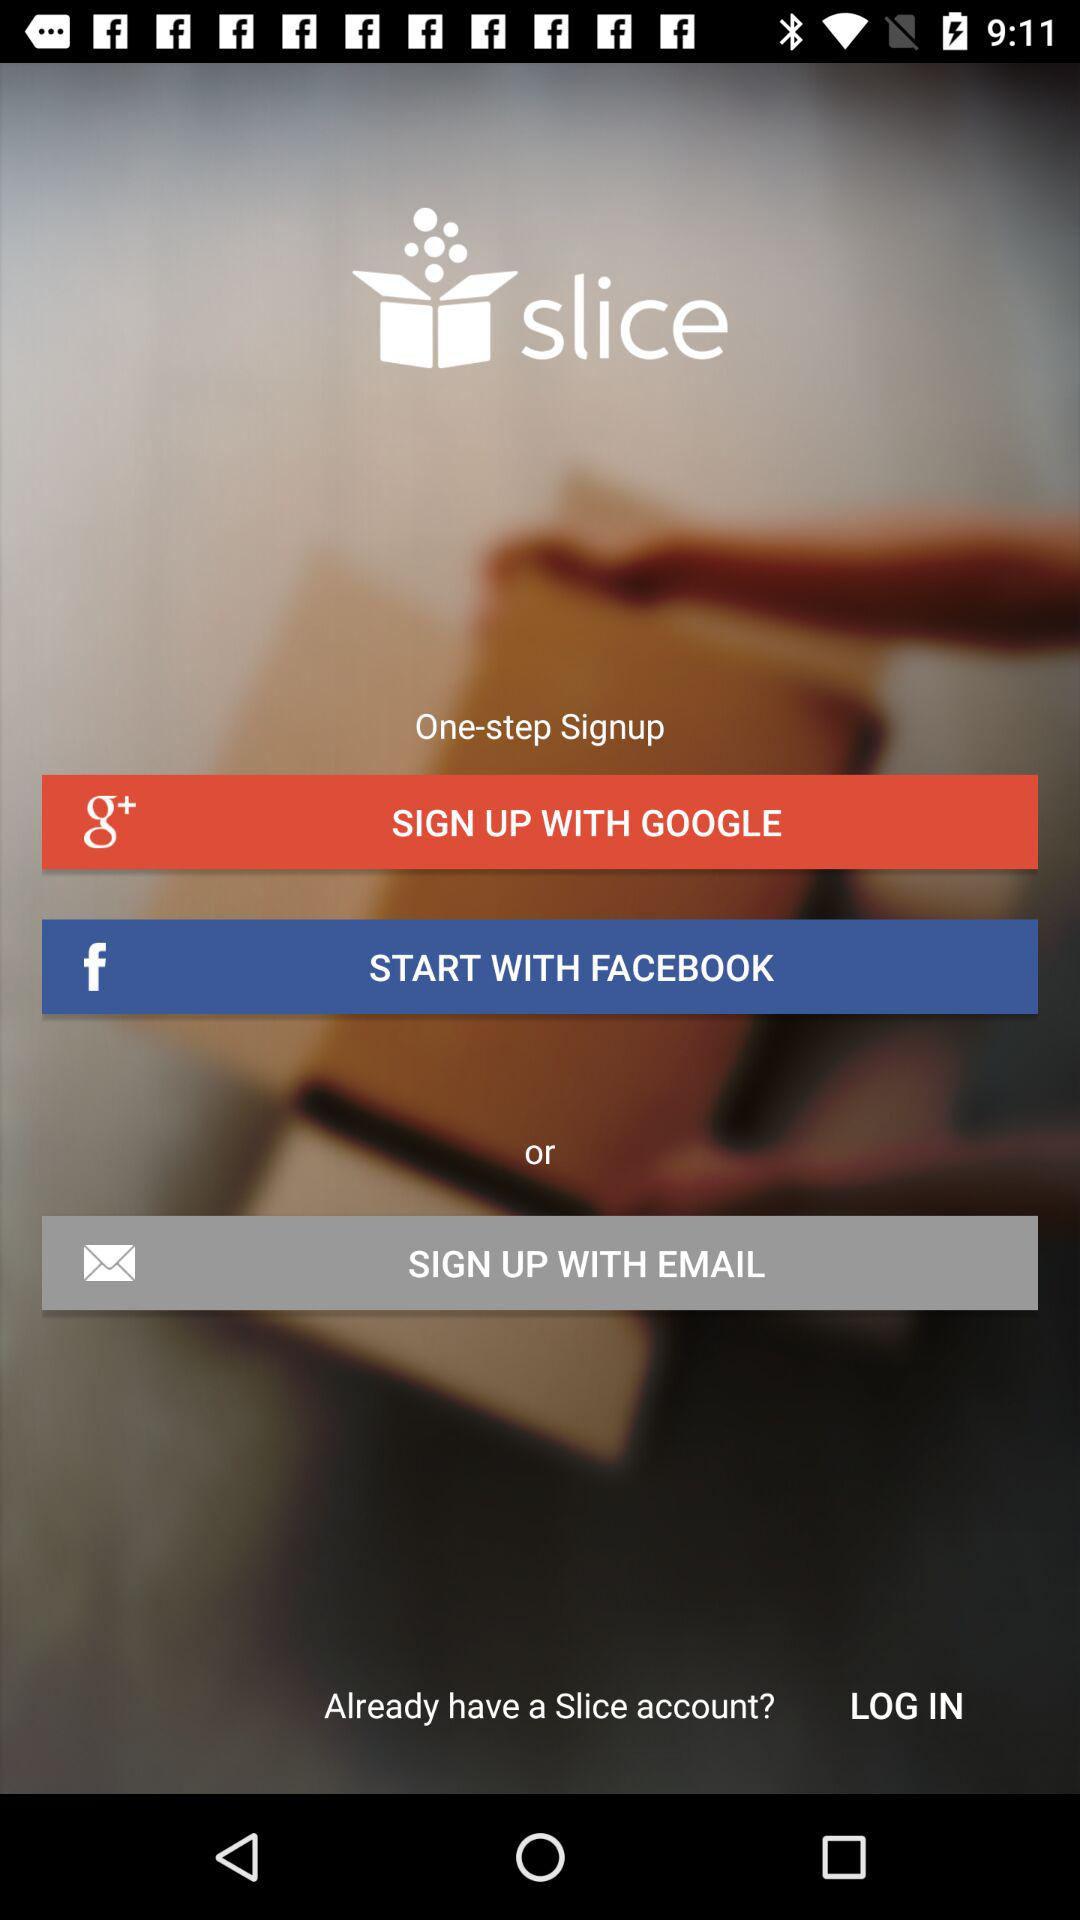Is a personal email address required to create an account with "Slice"?
When the provided information is insufficient, respond with <no answer>. <no answer> 